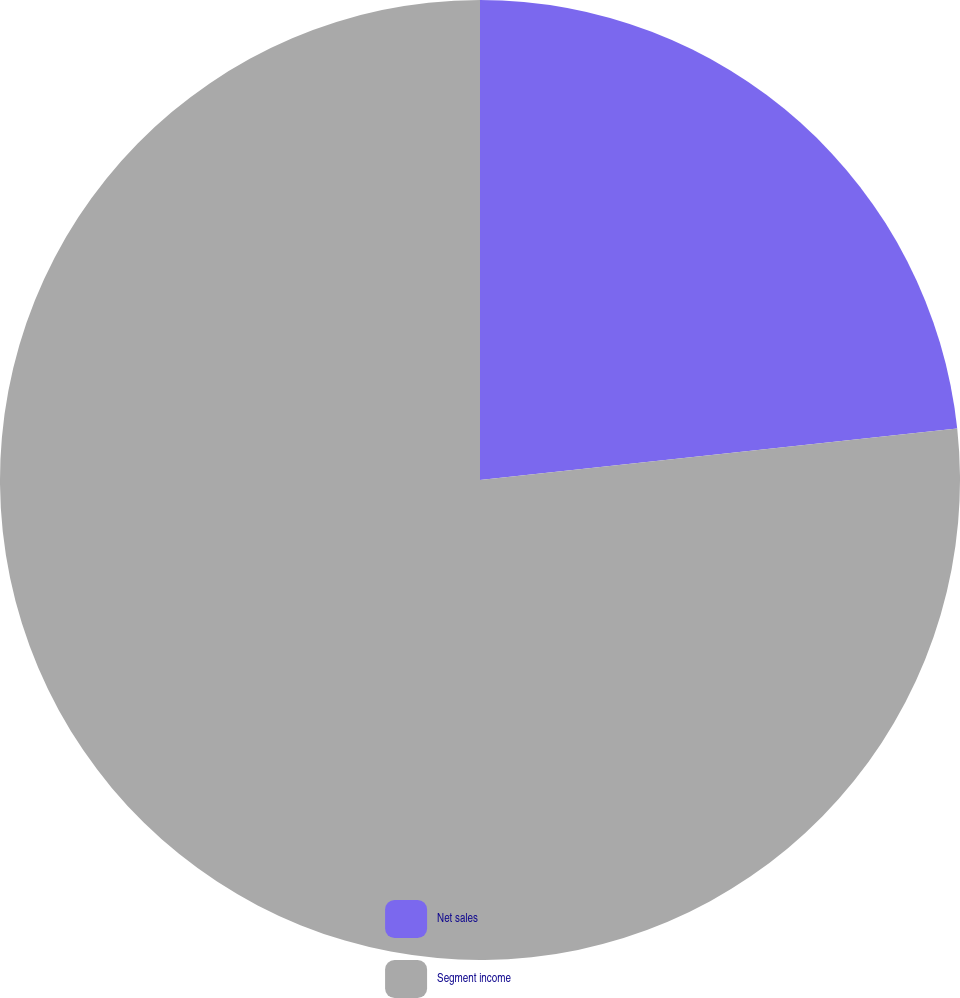Convert chart to OTSL. <chart><loc_0><loc_0><loc_500><loc_500><pie_chart><fcel>Net sales<fcel>Segment income<nl><fcel>23.29%<fcel>76.71%<nl></chart> 